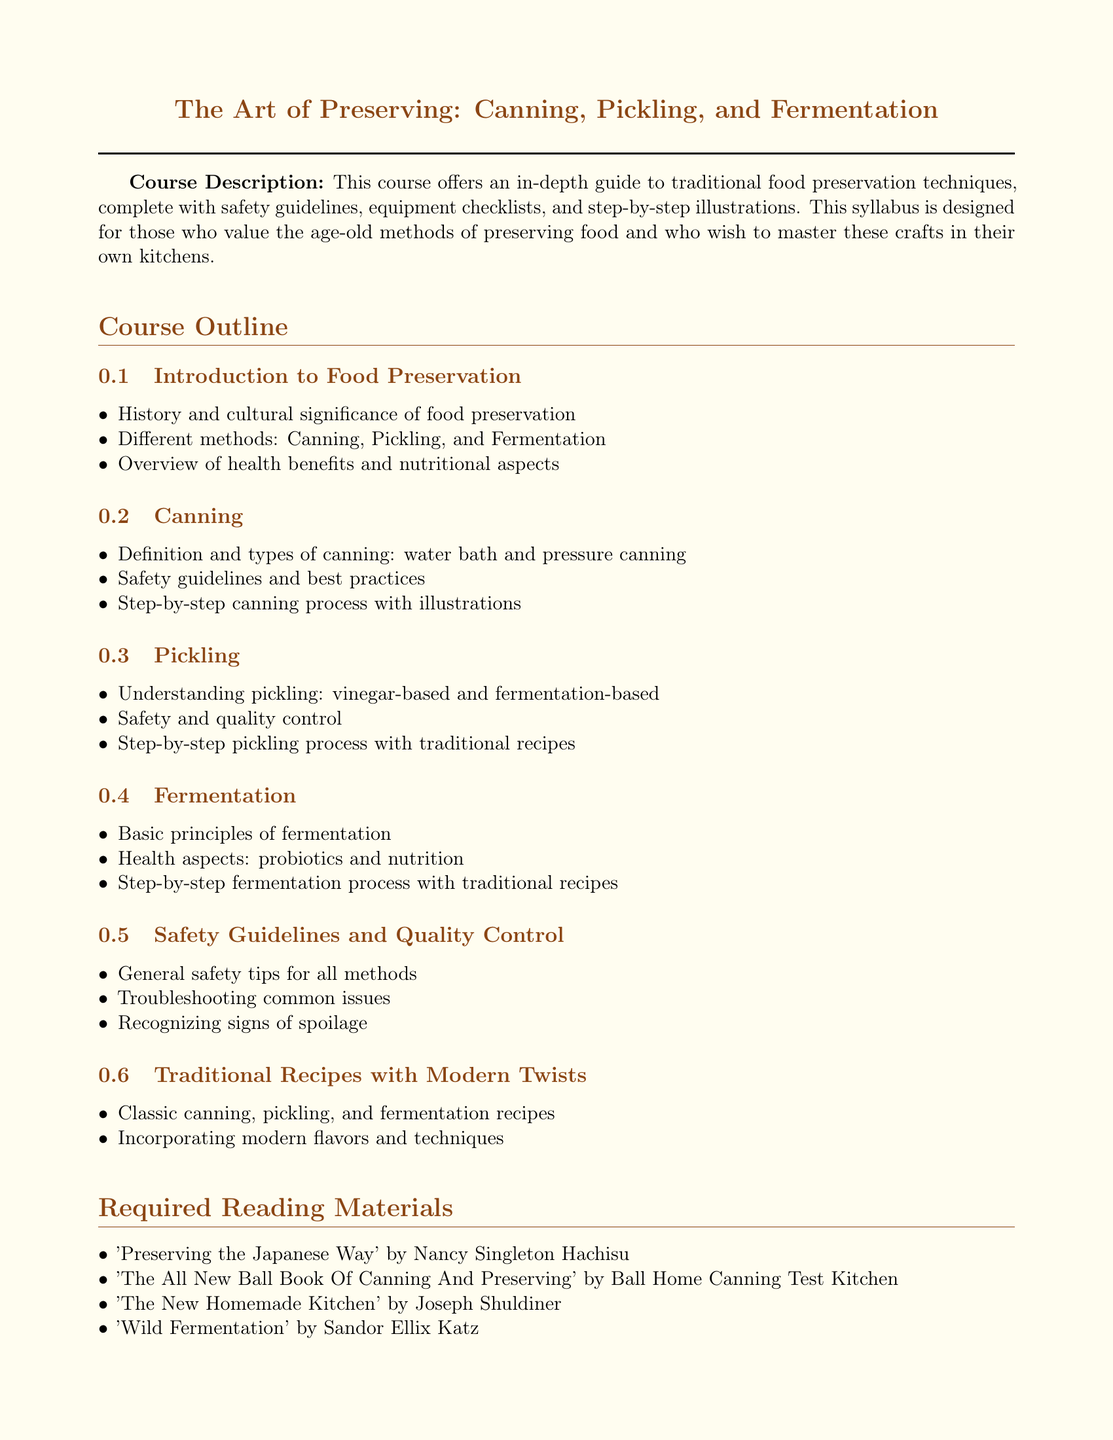What is the title of the course? The title is prominently displayed at the beginning of the document.
Answer: The Art of Preserving: Canning, Pickling, and Fermentation How many sections are in the course outline? The course outline has six distinct sections listed.
Answer: Six Who is the author of "Preserving the Japanese Way"? The required reading materials include several titles with authors named.
Answer: Nancy Singleton Hachisu What is one of the health aspects covered in fermentation? The course outline mentions specific health benefits related to fermentation.
Answer: Probiotics What type of canning is defined in the syllabus? The section on canning describes specific types in combination.
Answer: Water bath and pressure canning What is the purpose of the additional resources section? This section lists various resources that support the course material.
Answer: Support and recipe ideas What safety aspect is addressed in the guidelines? The syllabus mentions recognizing problematic signs ensuring safety.
Answer: Signs of spoilage How many traditional recipes are mentioned in the syllabus? The course outline refers to classic recipes used in traditional practices.
Answer: Classic recipes What is the primary focus of the course? The course aims to teach methods of food preservation that have been used traditionally.
Answer: Traditional food preservation techniques 